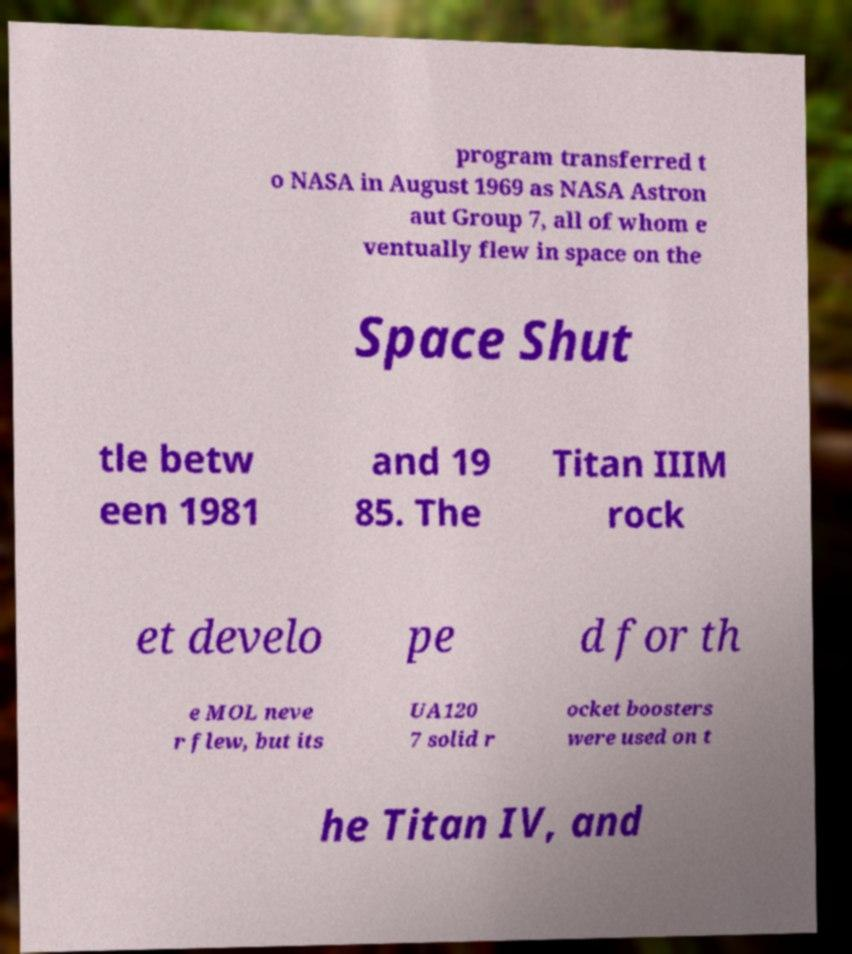I need the written content from this picture converted into text. Can you do that? program transferred t o NASA in August 1969 as NASA Astron aut Group 7, all of whom e ventually flew in space on the Space Shut tle betw een 1981 and 19 85. The Titan IIIM rock et develo pe d for th e MOL neve r flew, but its UA120 7 solid r ocket boosters were used on t he Titan IV, and 